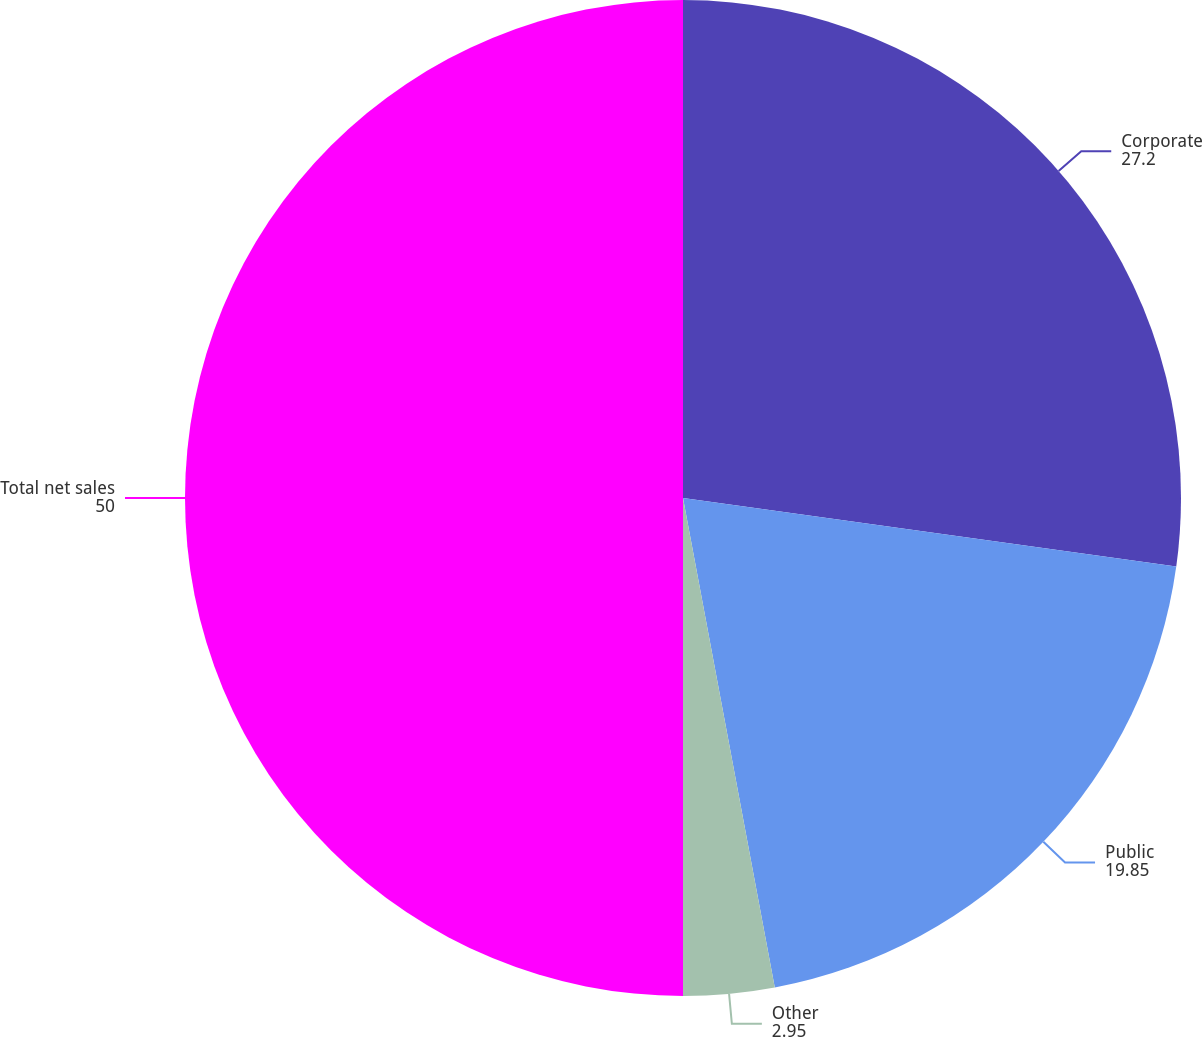<chart> <loc_0><loc_0><loc_500><loc_500><pie_chart><fcel>Corporate<fcel>Public<fcel>Other<fcel>Total net sales<nl><fcel>27.2%<fcel>19.85%<fcel>2.95%<fcel>50.0%<nl></chart> 